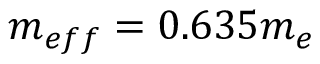<formula> <loc_0><loc_0><loc_500><loc_500>m _ { e f f } = 0 . 6 3 5 m _ { e }</formula> 